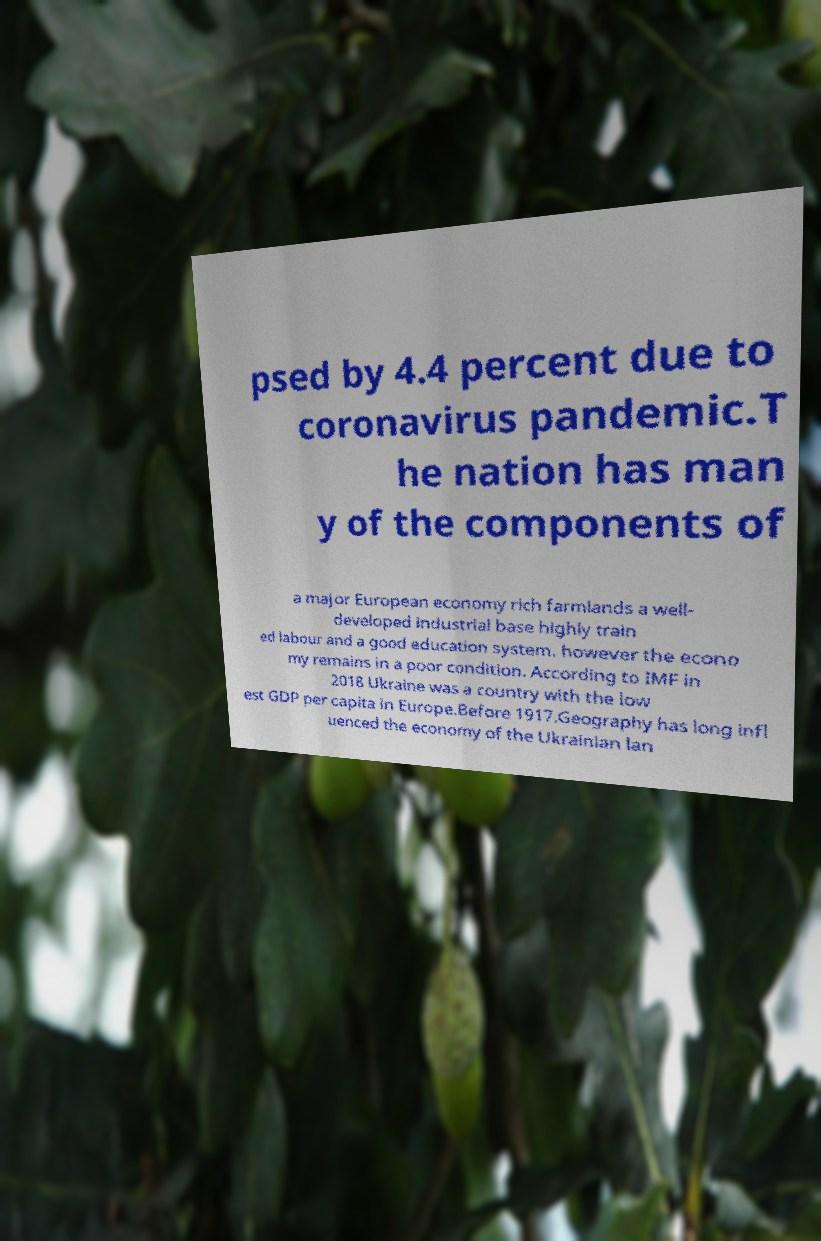Please identify and transcribe the text found in this image. psed by 4.4 percent due to coronavirus pandemic.T he nation has man y of the components of a major European economy rich farmlands a well- developed industrial base highly train ed labour and a good education system. however the econo my remains in a poor condition. According to IMF in 2018 Ukraine was a country with the low est GDP per capita in Europe.Before 1917.Geography has long infl uenced the economy of the Ukrainian lan 